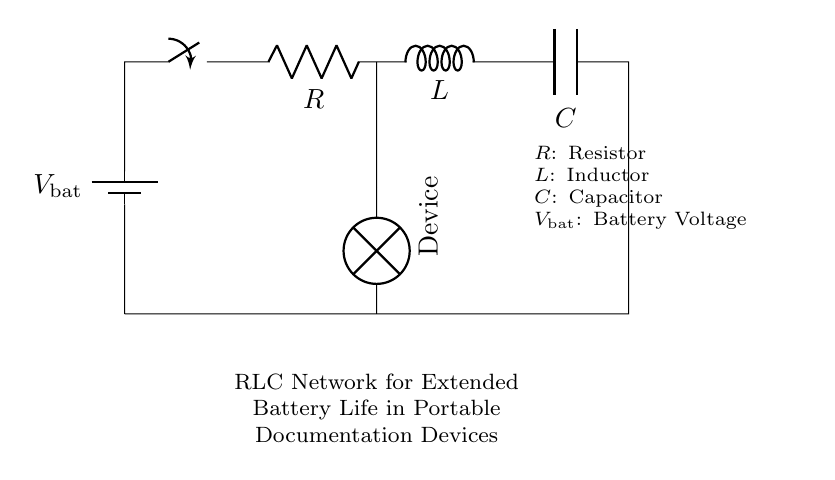What components are present in this circuit? The circuit includes a battery, a resistor, an inductor, and a capacitor. These components are visually labeled in the circuit diagram.
Answer: battery, resistor, inductor, capacitor What is the role of the battery in this circuit? The battery provides the voltage needed to power the circuit, serving as the energy source for the passive RLC network.
Answer: energy source What type of circuit is represented here? The circuit is a passive RLC (Resistor-Inductor-Capacitor) network, used for filtering or energy storage in portable documentation devices.
Answer: passive RLC network How can this RLC network help extend battery life? The RLC network can help manage and reduce current spikes, controlling the discharge rate and ensuring more efficient use of the battery's energy.
Answer: manages current spikes What happens if the resistor value is increased? Increasing the resistor value will reduce the current flowing through the circuit, which may lead to longer battery life but can also affect the performance of the connected device.
Answer: reduces current What does the inductor do in this circuit? The inductor stores energy in a magnetic field when current flows through it, aiding in smoothing out current flow and contributing to the stability of the circuit.
Answer: stores energy What is the function of the capacitor in this setup? The capacitor stores electrical energy when charged and releases it when needed, helping to maintain voltage levels and smooth out fluctuations in the circuit.
Answer: maintains voltage 